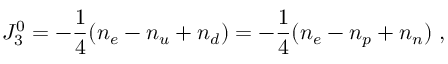Convert formula to latex. <formula><loc_0><loc_0><loc_500><loc_500>J _ { 3 } ^ { 0 } = - \frac { 1 } { 4 } ( n _ { e } - n _ { u } + n _ { d } ) = - \frac { 1 } { 4 } ( n _ { e } - n _ { p } + n _ { n } ) \, ,</formula> 